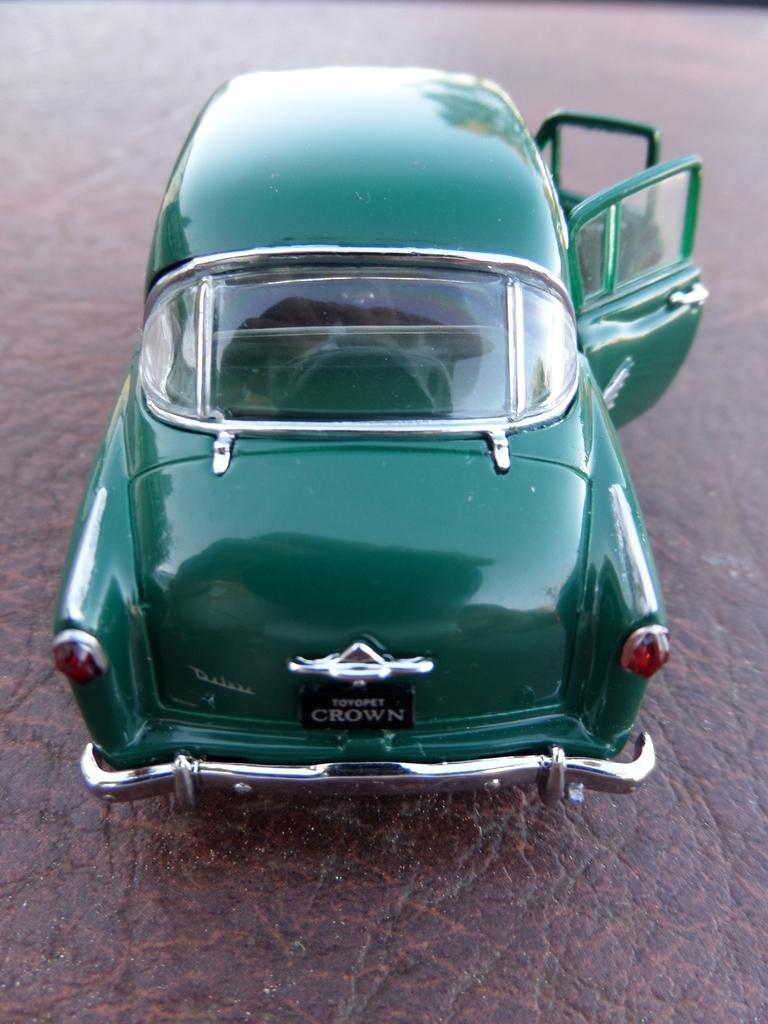What type of toy can be seen in the image? There is a green toy car in the image. What material is the object at the bottom of the image made of? The object at the bottom of the image is made of leather. What word is being spoken by the ghost in the image? There is no ghost present in the image, so it is not possible to answer that question. 